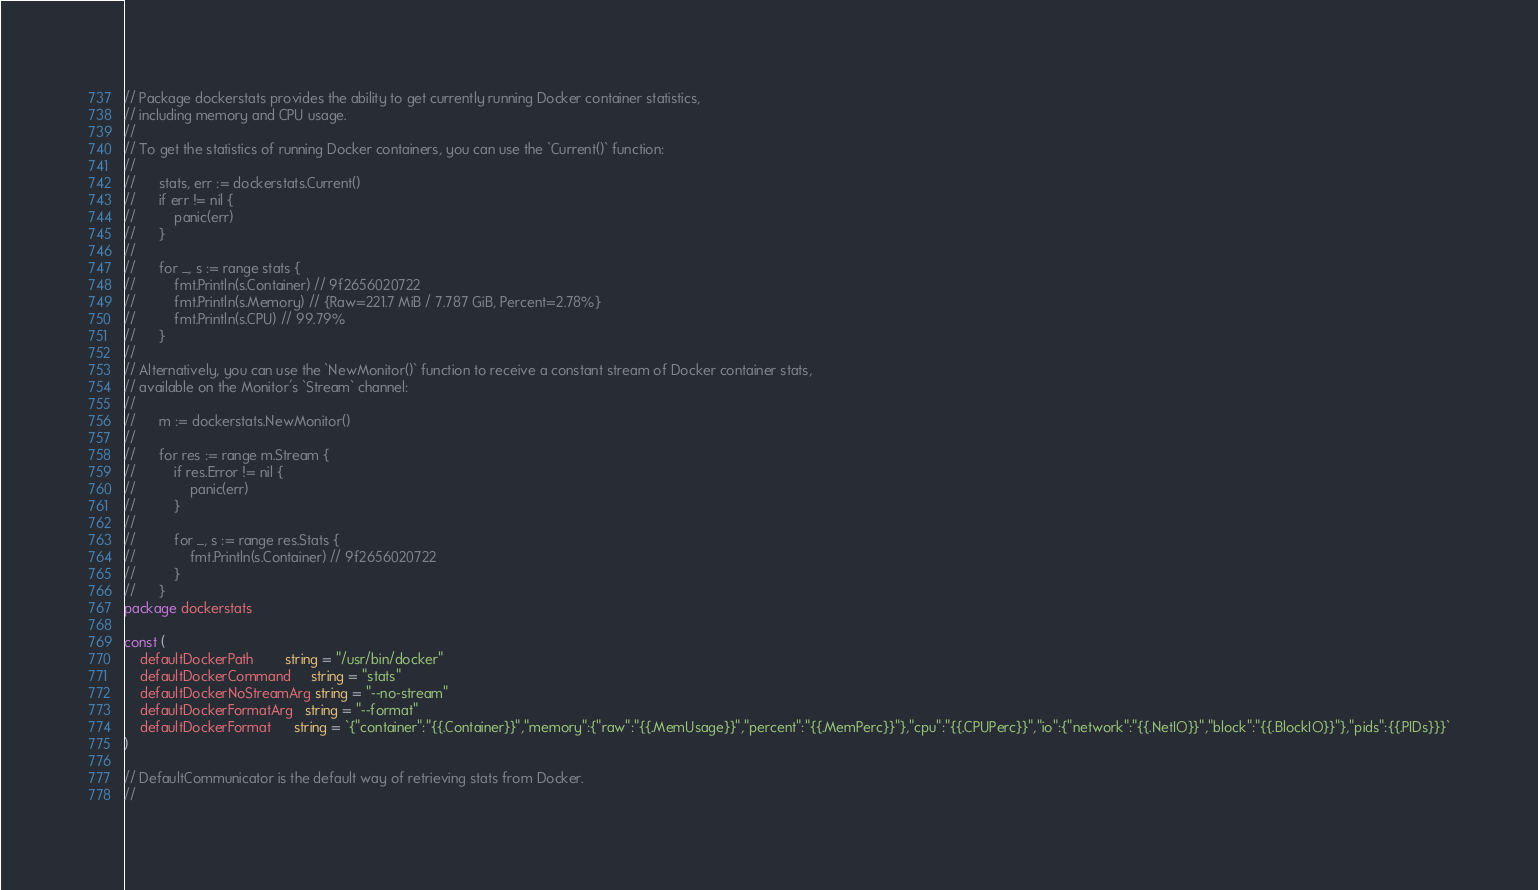Convert code to text. <code><loc_0><loc_0><loc_500><loc_500><_Go_>// Package dockerstats provides the ability to get currently running Docker container statistics,
// including memory and CPU usage.
//
// To get the statistics of running Docker containers, you can use the `Current()` function:
//
// 		stats, err := dockerstats.Current()
//		if err != nil {
//			panic(err)
//		}
//
//		for _, s := range stats {
//			fmt.Println(s.Container) // 9f2656020722
//			fmt.Println(s.Memory) // {Raw=221.7 MiB / 7.787 GiB, Percent=2.78%}
//			fmt.Println(s.CPU) // 99.79%
//		}
//
// Alternatively, you can use the `NewMonitor()` function to receive a constant stream of Docker container stats,
// available on the Monitor's `Stream` channel:
//
// 		m := dockerstats.NewMonitor()
//
// 		for res := range m.Stream {
//			if res.Error != nil {
//				panic(err)
//			}
//
//			for _, s := range res.Stats {
//				fmt.Println(s.Container) // 9f2656020722
//			}
// 		}
package dockerstats

const (
	defaultDockerPath        string = "/usr/bin/docker"
	defaultDockerCommand     string = "stats"
	defaultDockerNoStreamArg string = "--no-stream"
	defaultDockerFormatArg   string = "--format"
	defaultDockerFormat      string = `{"container":"{{.Container}}","memory":{"raw":"{{.MemUsage}}","percent":"{{.MemPerc}}"},"cpu":"{{.CPUPerc}}","io":{"network":"{{.NetIO}}","block":"{{.BlockIO}}"},"pids":{{.PIDs}}}`
)

// DefaultCommunicator is the default way of retrieving stats from Docker.
//</code> 